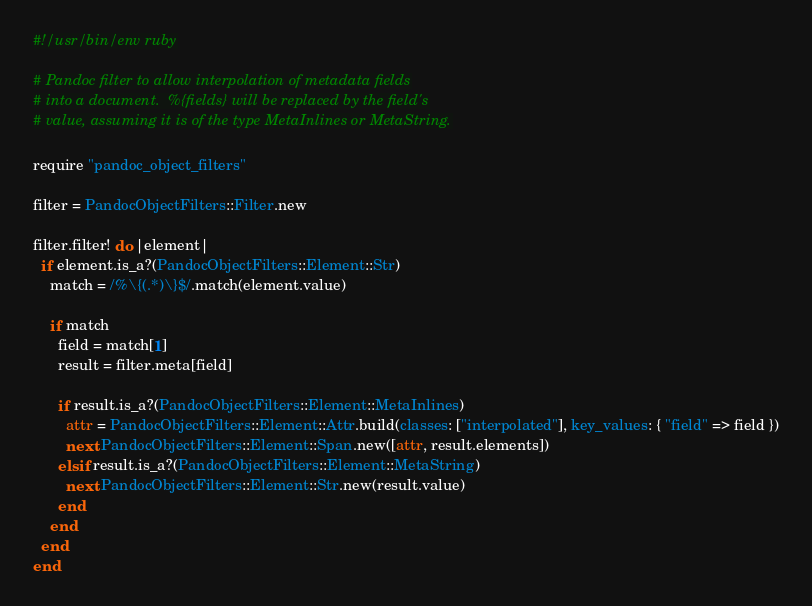Convert code to text. <code><loc_0><loc_0><loc_500><loc_500><_Ruby_>#!/usr/bin/env ruby

# Pandoc filter to allow interpolation of metadata fields
# into a document.  %{fields} will be replaced by the field's
# value, assuming it is of the type MetaInlines or MetaString.

require "pandoc_object_filters"

filter = PandocObjectFilters::Filter.new

filter.filter! do |element|
  if element.is_a?(PandocObjectFilters::Element::Str)
    match = /%\{(.*)\}$/.match(element.value)

    if match
      field = match[1]
      result = filter.meta[field]

      if result.is_a?(PandocObjectFilters::Element::MetaInlines)
        attr = PandocObjectFilters::Element::Attr.build(classes: ["interpolated"], key_values: { "field" => field })
        next PandocObjectFilters::Element::Span.new([attr, result.elements])
      elsif result.is_a?(PandocObjectFilters::Element::MetaString)
        next PandocObjectFilters::Element::Str.new(result.value)
      end
    end
  end
end
</code> 